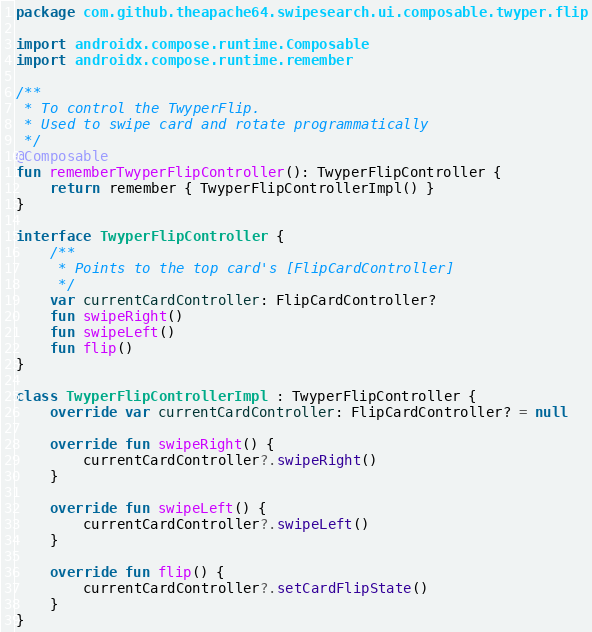Convert code to text. <code><loc_0><loc_0><loc_500><loc_500><_Kotlin_>package com.github.theapache64.swipesearch.ui.composable.twyper.flip

import androidx.compose.runtime.Composable
import androidx.compose.runtime.remember

/**
 * To control the TwyperFlip.
 * Used to swipe card and rotate programmatically
 */
@Composable
fun rememberTwyperFlipController(): TwyperFlipController {
    return remember { TwyperFlipControllerImpl() }
}

interface TwyperFlipController {
    /**
     * Points to the top card's [FlipCardController]
     */
    var currentCardController: FlipCardController?
    fun swipeRight()
    fun swipeLeft()
    fun flip()
}

class TwyperFlipControllerImpl : TwyperFlipController {
    override var currentCardController: FlipCardController? = null

    override fun swipeRight() {
        currentCardController?.swipeRight()
    }

    override fun swipeLeft() {
        currentCardController?.swipeLeft()
    }

    override fun flip() {
        currentCardController?.setCardFlipState()
    }
}</code> 